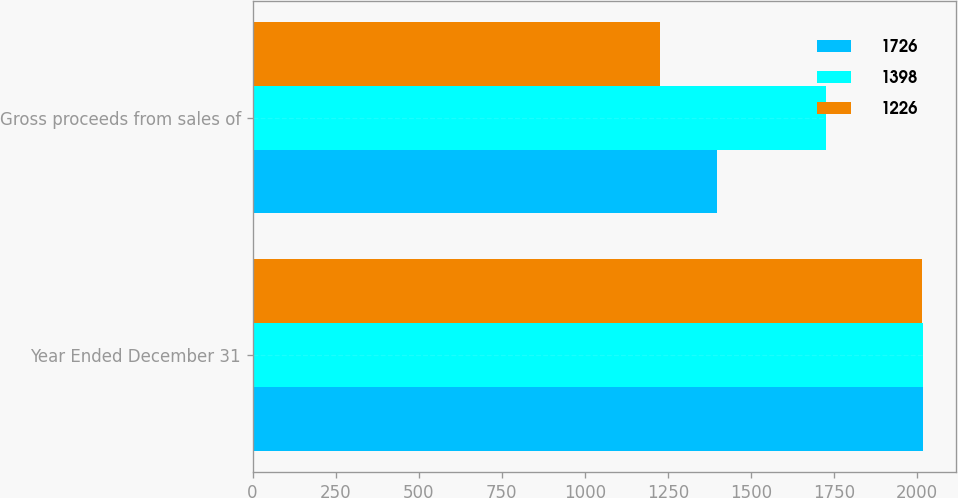Convert chart to OTSL. <chart><loc_0><loc_0><loc_500><loc_500><stacked_bar_chart><ecel><fcel>Year Ended December 31<fcel>Gross proceeds from sales of<nl><fcel>1726<fcel>2017<fcel>1398<nl><fcel>1398<fcel>2016<fcel>1726<nl><fcel>1226<fcel>2015<fcel>1226<nl></chart> 